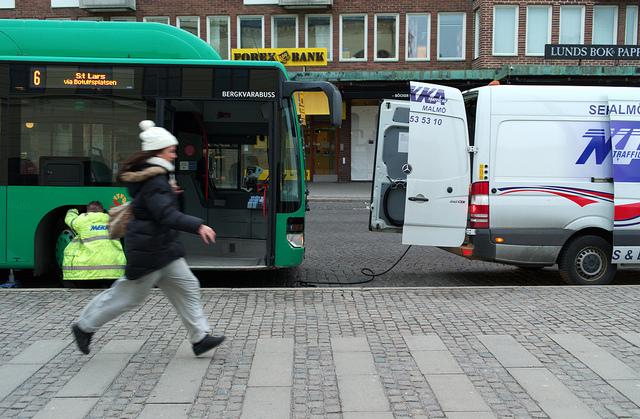What is on the woman's head?
Concise answer only. Hat. Is the person running?
Answer briefly. Yes. Is the woman running for the bus?
Write a very short answer. No. 